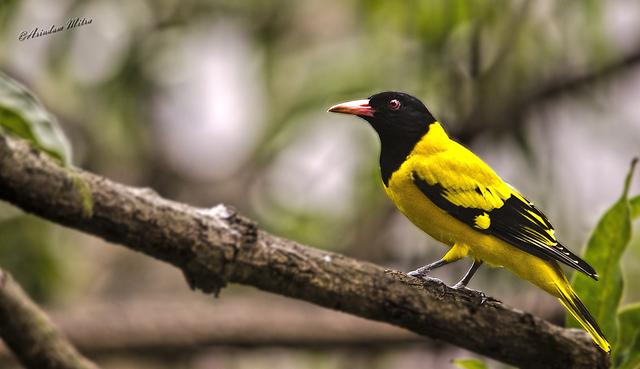Is this a dragon?
Keep it brief. No. What is on the bird's leg?
Write a very short answer. Nothing. What color is the bird's underbelly?
Answer briefly. Yellow. How many birds are in the background?
Be succinct. 0. 